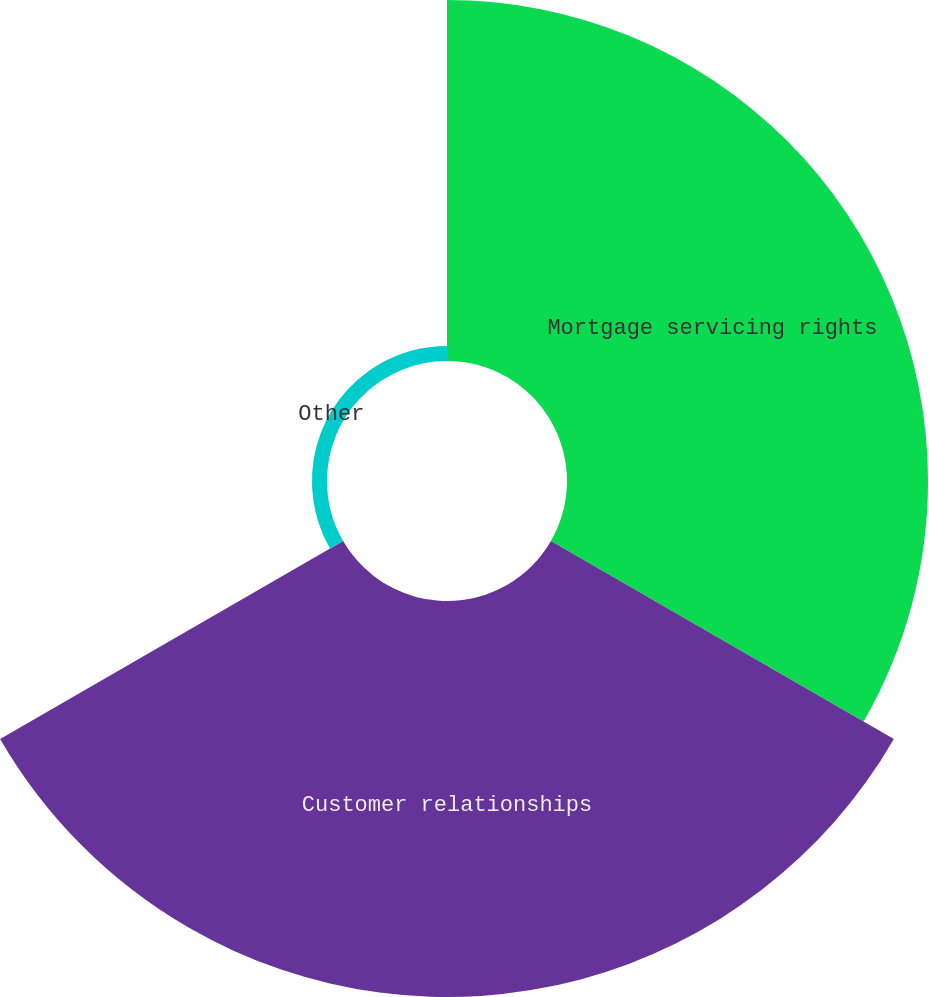<chart> <loc_0><loc_0><loc_500><loc_500><pie_chart><fcel>Mortgage servicing rights<fcel>Customer relationships<fcel>Other<nl><fcel>46.76%<fcel>51.29%<fcel>1.95%<nl></chart> 